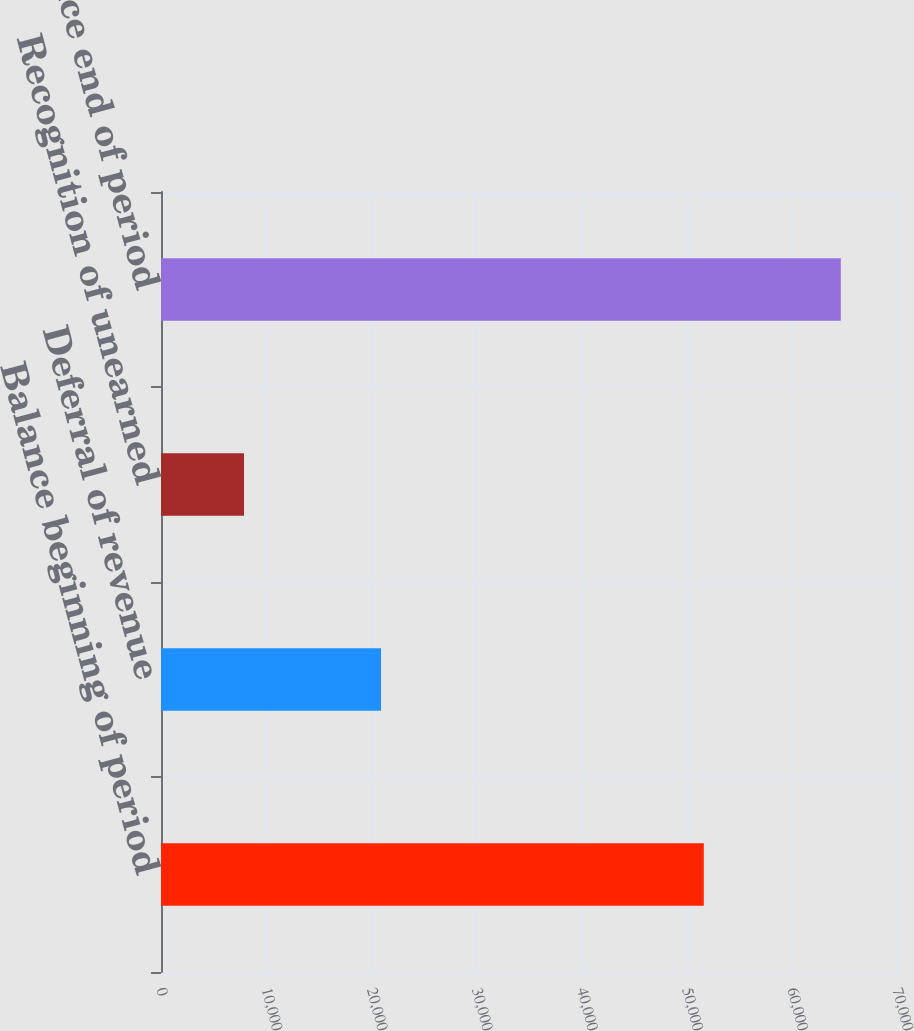<chart> <loc_0><loc_0><loc_500><loc_500><bar_chart><fcel>Balance beginning of period<fcel>Deferral of revenue<fcel>Recognition of unearned<fcel>Balance end of period<nl><fcel>51624<fcel>20925<fcel>7898<fcel>64651<nl></chart> 